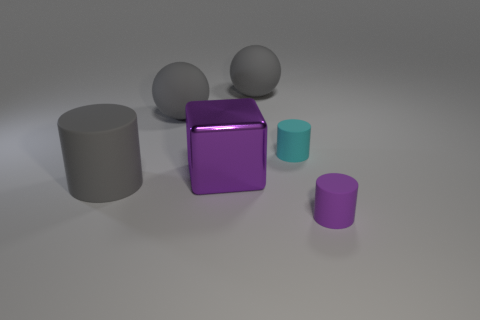Subtract all small cylinders. How many cylinders are left? 1 Subtract all cyan cylinders. How many cylinders are left? 2 Subtract all blocks. How many objects are left? 5 Subtract 1 balls. How many balls are left? 1 Subtract all yellow cylinders. Subtract all red cubes. How many cylinders are left? 3 Subtract all cyan balls. How many purple cylinders are left? 1 Subtract all gray objects. Subtract all large metallic objects. How many objects are left? 2 Add 1 small rubber cylinders. How many small rubber cylinders are left? 3 Add 4 gray cylinders. How many gray cylinders exist? 5 Add 1 large purple shiny things. How many objects exist? 7 